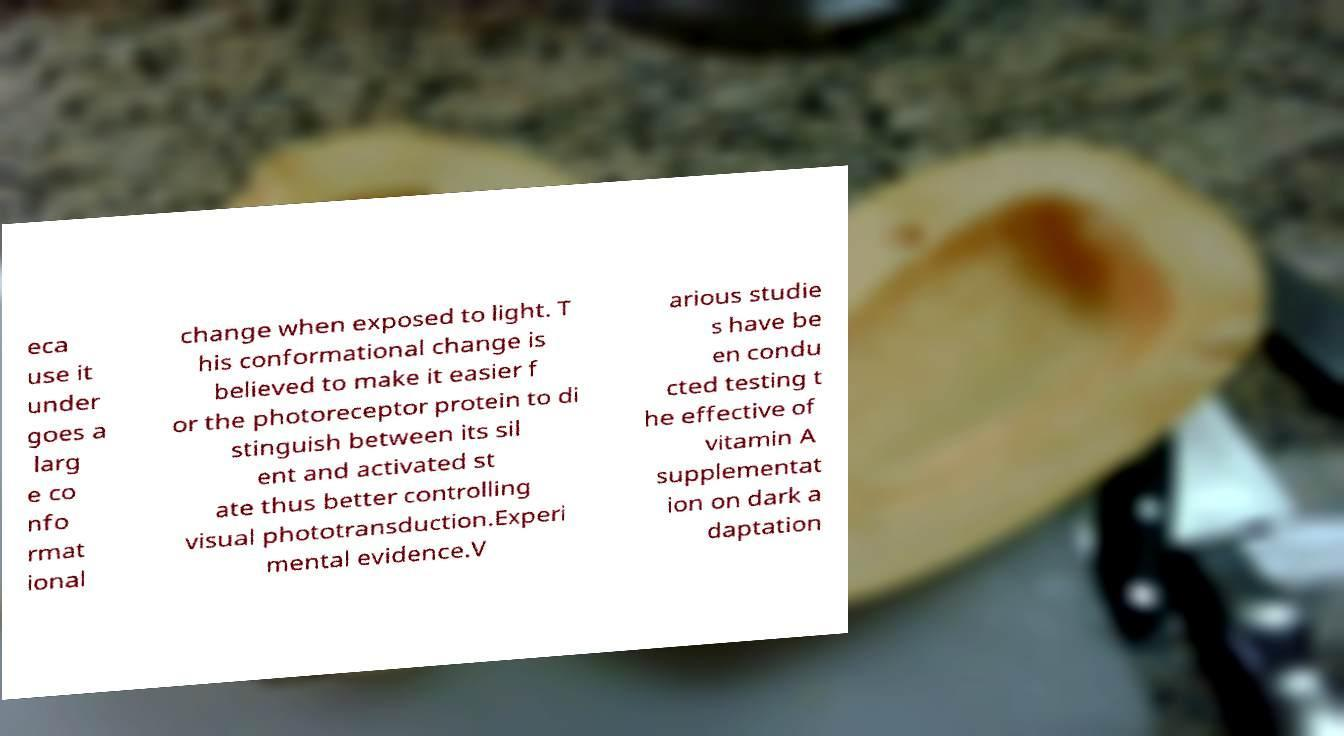Please read and relay the text visible in this image. What does it say? eca use it under goes a larg e co nfo rmat ional change when exposed to light. T his conformational change is believed to make it easier f or the photoreceptor protein to di stinguish between its sil ent and activated st ate thus better controlling visual phototransduction.Experi mental evidence.V arious studie s have be en condu cted testing t he effective of vitamin A supplementat ion on dark a daptation 